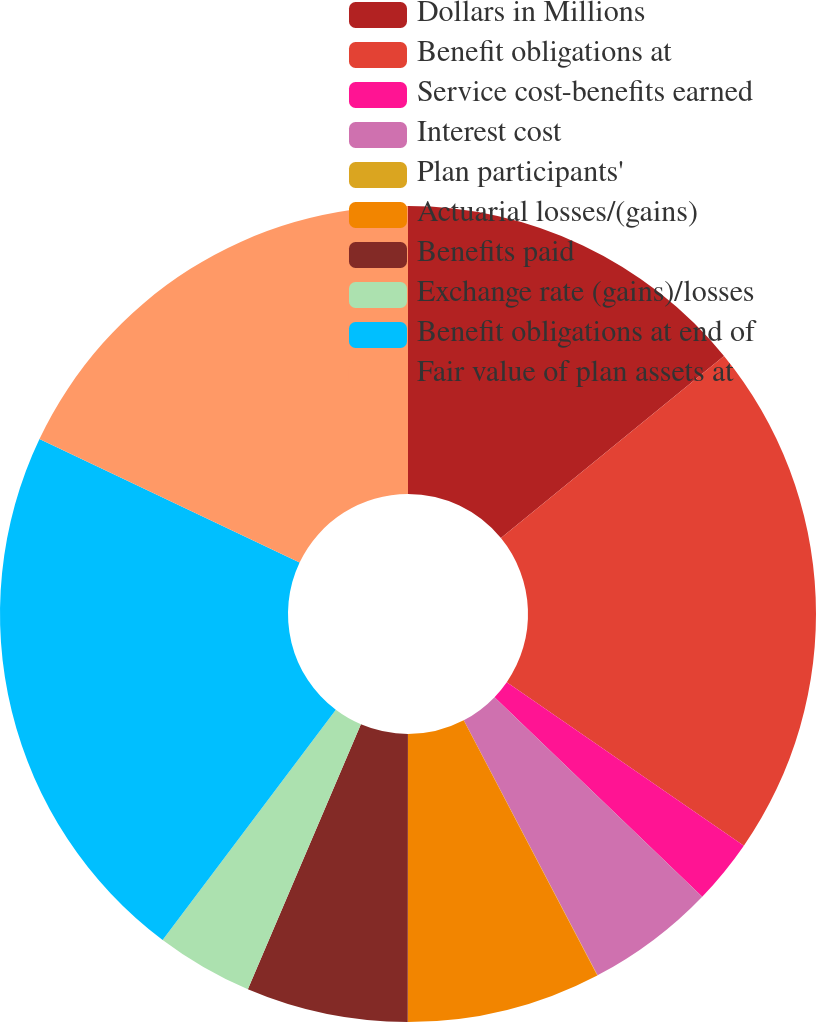Convert chart to OTSL. <chart><loc_0><loc_0><loc_500><loc_500><pie_chart><fcel>Dollars in Millions<fcel>Benefit obligations at<fcel>Service cost-benefits earned<fcel>Interest cost<fcel>Plan participants'<fcel>Actuarial losses/(gains)<fcel>Benefits paid<fcel>Exchange rate (gains)/losses<fcel>Benefit obligations at end of<fcel>Fair value of plan assets at<nl><fcel>14.1%<fcel>20.51%<fcel>2.57%<fcel>5.13%<fcel>0.01%<fcel>7.69%<fcel>6.41%<fcel>3.85%<fcel>21.79%<fcel>17.94%<nl></chart> 